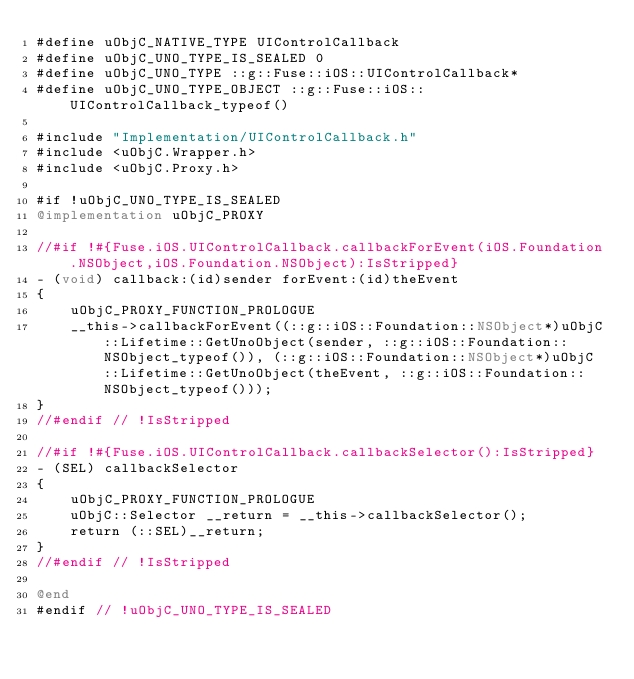<code> <loc_0><loc_0><loc_500><loc_500><_ObjectiveC_>#define uObjC_NATIVE_TYPE UIControlCallback
#define uObjC_UNO_TYPE_IS_SEALED 0
#define uObjC_UNO_TYPE ::g::Fuse::iOS::UIControlCallback*
#define uObjC_UNO_TYPE_OBJECT ::g::Fuse::iOS::UIControlCallback_typeof()

#include "Implementation/UIControlCallback.h"
#include <uObjC.Wrapper.h>
#include <uObjC.Proxy.h>

#if !uObjC_UNO_TYPE_IS_SEALED
@implementation uObjC_PROXY

//#if !#{Fuse.iOS.UIControlCallback.callbackForEvent(iOS.Foundation.NSObject,iOS.Foundation.NSObject):IsStripped}
- (void) callback:(id)sender forEvent:(id)theEvent
{
    uObjC_PROXY_FUNCTION_PROLOGUE
    __this->callbackForEvent((::g::iOS::Foundation::NSObject*)uObjC::Lifetime::GetUnoObject(sender, ::g::iOS::Foundation::NSObject_typeof()), (::g::iOS::Foundation::NSObject*)uObjC::Lifetime::GetUnoObject(theEvent, ::g::iOS::Foundation::NSObject_typeof()));
}
//#endif // !IsStripped

//#if !#{Fuse.iOS.UIControlCallback.callbackSelector():IsStripped}
- (SEL) callbackSelector
{
    uObjC_PROXY_FUNCTION_PROLOGUE
    uObjC::Selector __return = __this->callbackSelector();
    return (::SEL)__return;
}
//#endif // !IsStripped

@end
#endif // !uObjC_UNO_TYPE_IS_SEALED
</code> 